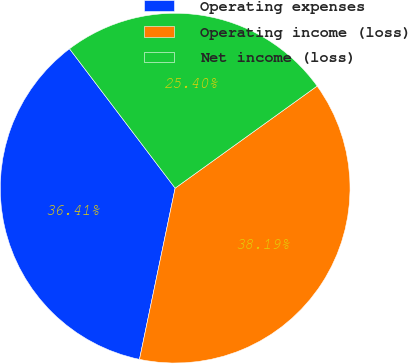Convert chart to OTSL. <chart><loc_0><loc_0><loc_500><loc_500><pie_chart><fcel>Operating expenses<fcel>Operating income (loss)<fcel>Net income (loss)<nl><fcel>36.41%<fcel>38.19%<fcel>25.4%<nl></chart> 